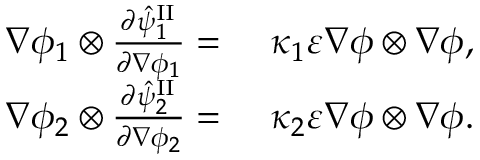<formula> <loc_0><loc_0><loc_500><loc_500>\begin{array} { r l } { \nabla \phi _ { 1 } \otimes \frac { \partial \hat { \psi } _ { 1 } ^ { I I } } { \partial \nabla \phi _ { 1 } } = } & \kappa _ { 1 } \varepsilon \nabla \phi \otimes \nabla \phi , } \\ { \nabla \phi _ { 2 } \otimes \frac { \partial \hat { \psi } _ { 2 } ^ { I I } } { \partial \nabla \phi _ { 2 } } = } & \kappa _ { 2 } \varepsilon \nabla \phi \otimes \nabla \phi . } \end{array}</formula> 